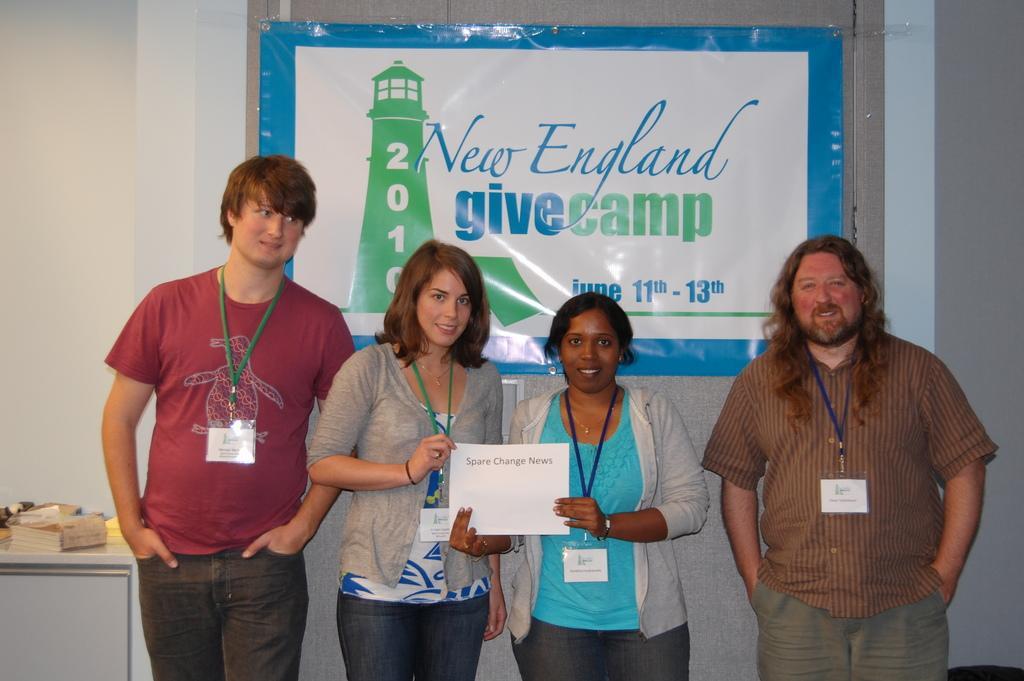How would you summarize this image in a sentence or two? Here in this picture we can see four people standing on the floor over there and we can see all of them are smiling and we can also see all of them are having ID cards on them and the two women in the middle are holding a certificate in their hand and behind them we can see a banner present on the wall over there and on the left side we can see a table, on which we can see something's present over there. 